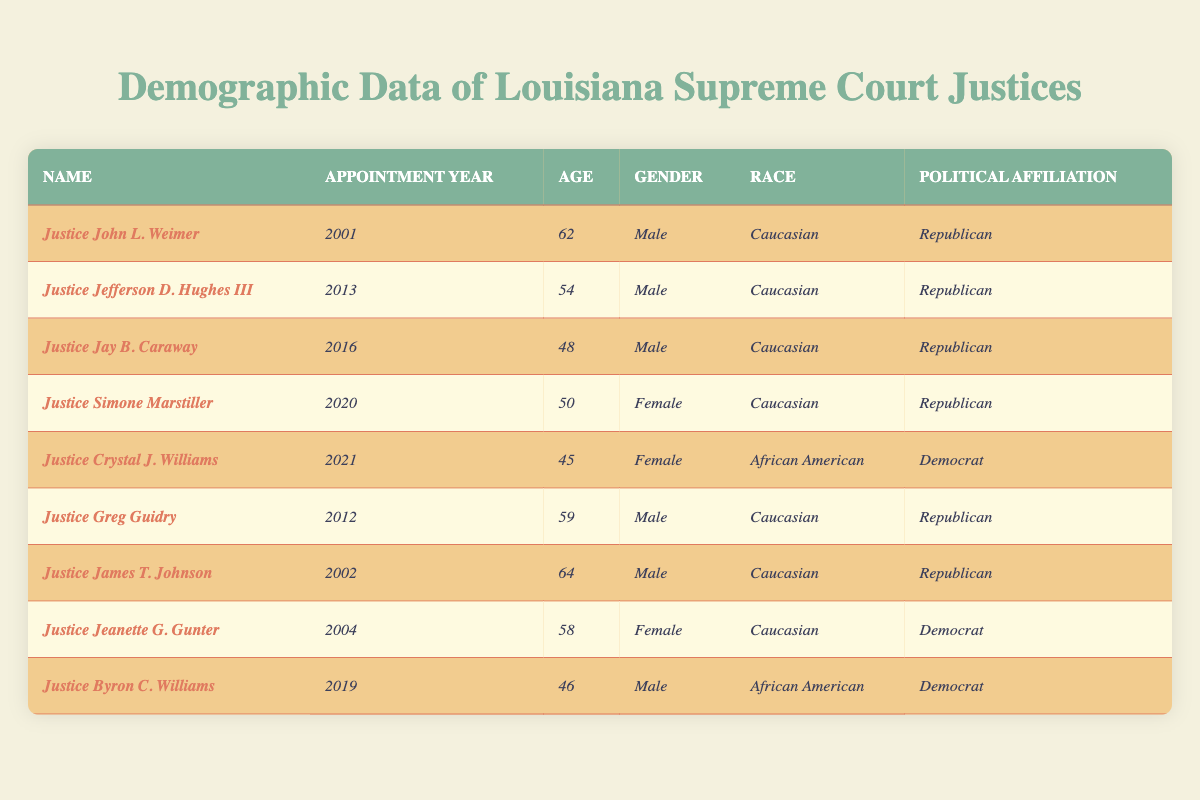What is the gender of Justice Simone Marstiller? In the table under the row for Justice Simone Marstiller, the gender is listed as Female.
Answer: Female Who was appointed to the Louisiana Supreme Court in 2021? The table shows that Justice Crystal J. Williams was appointed in 2021.
Answer: Justice Crystal J. Williams How many justices on the table are affiliated with the Republican Party? The justices identified as Republican are John L. Weimer, Jefferson D. Hughes III, Jay B. Caraway, Simone Marstiller, Greg Guidry, and James T. Johnson, totaling six justices.
Answer: 6 What is the average age of the justices in the table? The ages of the justices are 62, 54, 48, 50, 45, 59, 64, 58, and 46. Adding these gives 62 + 54 + 48 + 50 + 45 + 59 + 64 + 58 + 46 = 436. Then dividing by the number of justices (9), we get 436/9 = 48.44, which rounds to approximately 48.44.
Answer: 48.44 Is there a female justice connected to the Democratic Party? A look in the table shows that Justice Crystal J. Williams is a Female and has a Democratic affiliation.
Answer: Yes Which justice is the youngest in the table? The ages are compared: 62, 54, 48, 50, 45, 59, 64, 58, and 46. The youngest is Justice Crystal J. Williams at 45 years old.
Answer: Justice Crystal J. Williams How many justices are African American? Looking at the race data, there are two justices identified as African American: Justice Crystal J. Williams and Justice Byron C. Williams.
Answer: 2 What is the political affiliation of Justice Jeanette G. Gunter? The table indicates that Justice Jeanette G. Gunter’s political affiliation is Democratic.
Answer: Democrat Which justice appointed in 2012 is male? In the table, Justice Greg Guidry is listed as male and was appointed in 2012.
Answer: Justice Greg Guidry Are there more justices who are Caucasian or African American in the table? The table lists 7 justices as Caucasian and 2 as African American; therefore, there are more justices who are Caucasian.
Answer: Caucasian What is the age difference between the oldest and youngest justices? The oldest is Justice James T. Johnson at 64 and the youngest is Justice Crystal J. Williams at 45. The difference is 64 - 45 = 19 years.
Answer: 19 years 